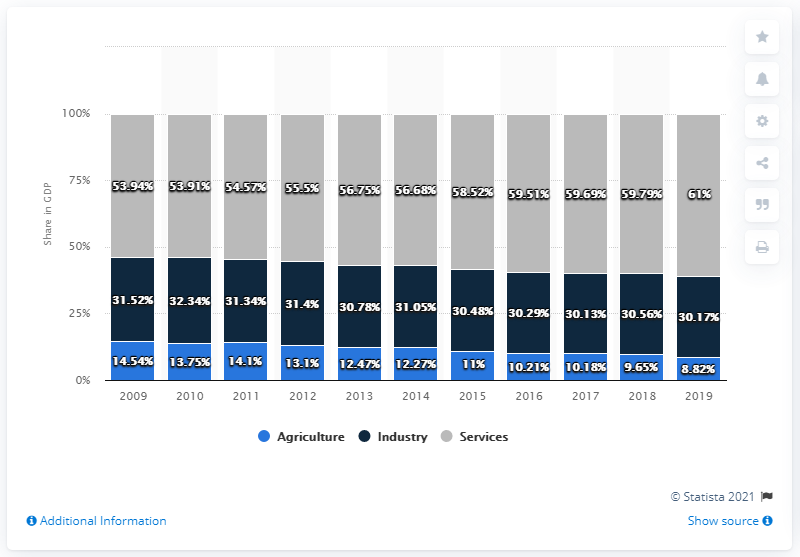Identify some key points in this picture. In 2019, the percentage of services in the Gross Domestic Product (GDP) was 61%. In the year 2014, the percentage of agriculture in the Gross Domestic Product (GDP) was 12.27%. 